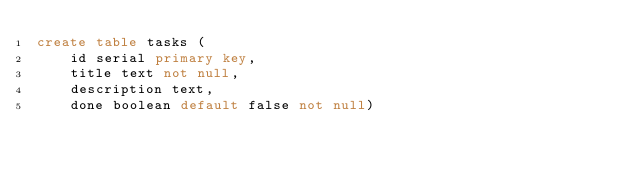Convert code to text. <code><loc_0><loc_0><loc_500><loc_500><_SQL_>create table tasks (
    id serial primary key,
    title text not null,
    description text,
    done boolean default false not null)
</code> 